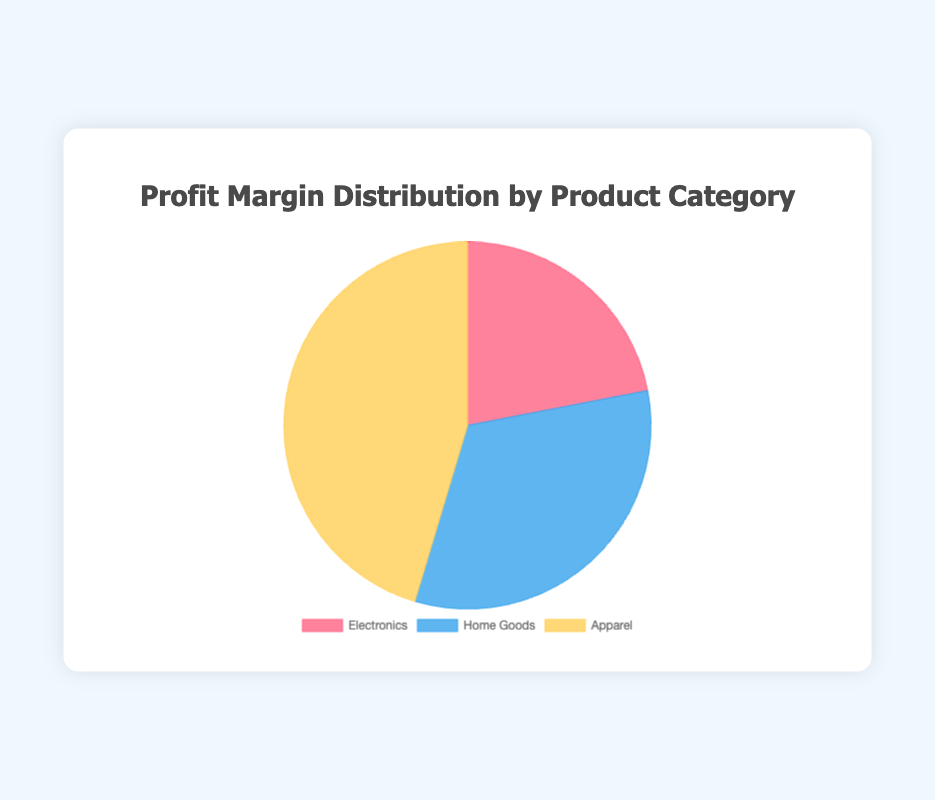Which product category has the highest average profit margin? The profit margins for each category are calculated as follows:
- Electronics: (0.15 + 0.12 + 0.18) / 3 = 0.15
- Home Goods: (0.25 + 0.20 + 0.22) / 3 = 0.2233
- Apparel: (0.30 + 0.28 + 0.35) / 3 = 0.31
The Apparel category has the highest average profit margin.
Answer: Apparel Which product category has the lowest average profit margin? The profit margins for each category are calculated as follows:
- Electronics: (0.15 + 0.12 + 0.18) / 3 = 0.15
- Home Goods: (0.25 + 0.20 + 0.22) / 3 = 0.2233
- Apparel: (0.30 + 0.28 + 0.35) / 3 = 0.31
The Electronics category has the lowest average profit margin.
Answer: Electronics What is the total profit margin of the Home Goods category if we sum the average profit margins of all its subcategories? The average profit margin of Home Goods subcategories is calculated as follows:
- Home Goods: (0.25 + 0.20 + 0.22) / 3 = 0.2233
So the total sum for Home Goods is 0.25 + 0.20 + 0.22 = 0.67.
Answer: 0.67 By how much is the average profit margin of the Apparel category higher than that of the Electronics category? The average profit margins are:
- Apparel: 0.31
- Electronics: 0.15
Subtraction: 0.31 - 0.15 = 0.16
Answer: 0.16 Which product category is represented by the yellow color? The pie chart's colors are:
- Red: Electronics
- Blue: Home Goods
- Yellow: Apparel
Therefore, the yellow color represents the Apparel category.
Answer: Apparel Compare the average profit margins of Electronics and Home Goods. Which is higher and by how much? The average profit margins are:
- Electronics: 0.15
- Home Goods: 0.2233
Subtraction: 0.2233 - 0.15 = 0.0733
Home Goods has a higher average profit margin than Electronics by 0.0733.
Answer: Home Goods, 0.0733 What is the combined weight of Electronics and Apparel categories in terms of the total average profit margin? The average profit margins are:
- Apparel: 0.31
- Electronics: 0.15
Sum: 0.31 + 0.15 = 0.46
Answer: 0.46 Is the average profit margin of Home Goods closer to that of Electronics or Apparel? The average profit margins are:
- Electronics: 0.15
- Home Goods: 0.2233
- Apparel: 0.31
The difference between Home Goods and Electronics: 0.2233 - 0.15 = 0.0733
The difference between Home Goods and Apparel: 0.31 - 0.2233 = 0.0867
Home Goods' margin is closer to that of Electronics.
Answer: Electronics 